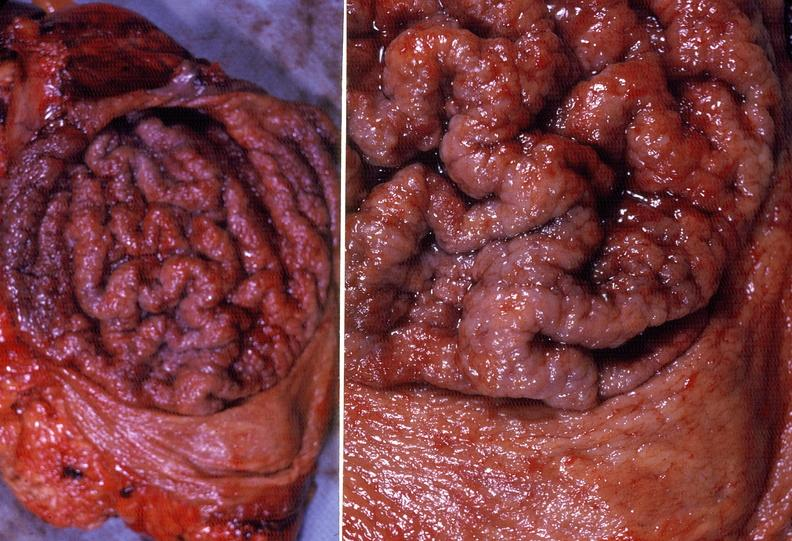s gastrointestinal present?
Answer the question using a single word or phrase. Yes 